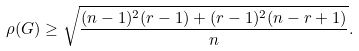Convert formula to latex. <formula><loc_0><loc_0><loc_500><loc_500>\rho ( G ) \geq \sqrt { \frac { ( n - 1 ) ^ { 2 } ( r - 1 ) + ( r - 1 ) ^ { 2 } ( n - r + 1 ) } { n } } .</formula> 